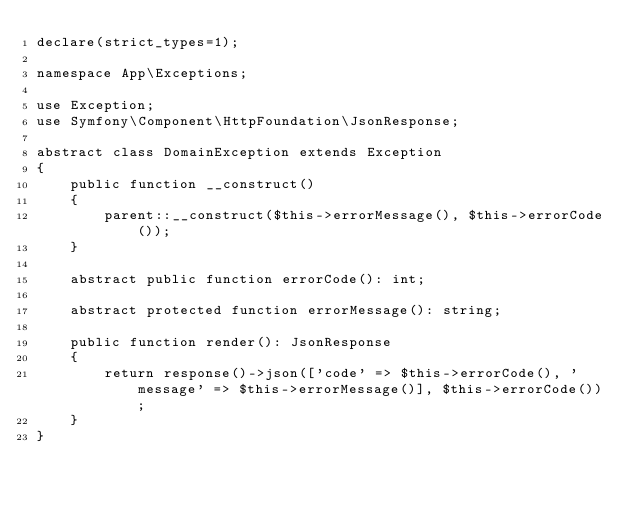Convert code to text. <code><loc_0><loc_0><loc_500><loc_500><_PHP_>declare(strict_types=1);

namespace App\Exceptions;

use Exception;
use Symfony\Component\HttpFoundation\JsonResponse;

abstract class DomainException extends Exception
{
    public function __construct()
    {
        parent::__construct($this->errorMessage(), $this->errorCode());
    }

    abstract public function errorCode(): int;

    abstract protected function errorMessage(): string;

    public function render(): JsonResponse
    {
        return response()->json(['code' => $this->errorCode(), 'message' => $this->errorMessage()], $this->errorCode());
    }
}
</code> 